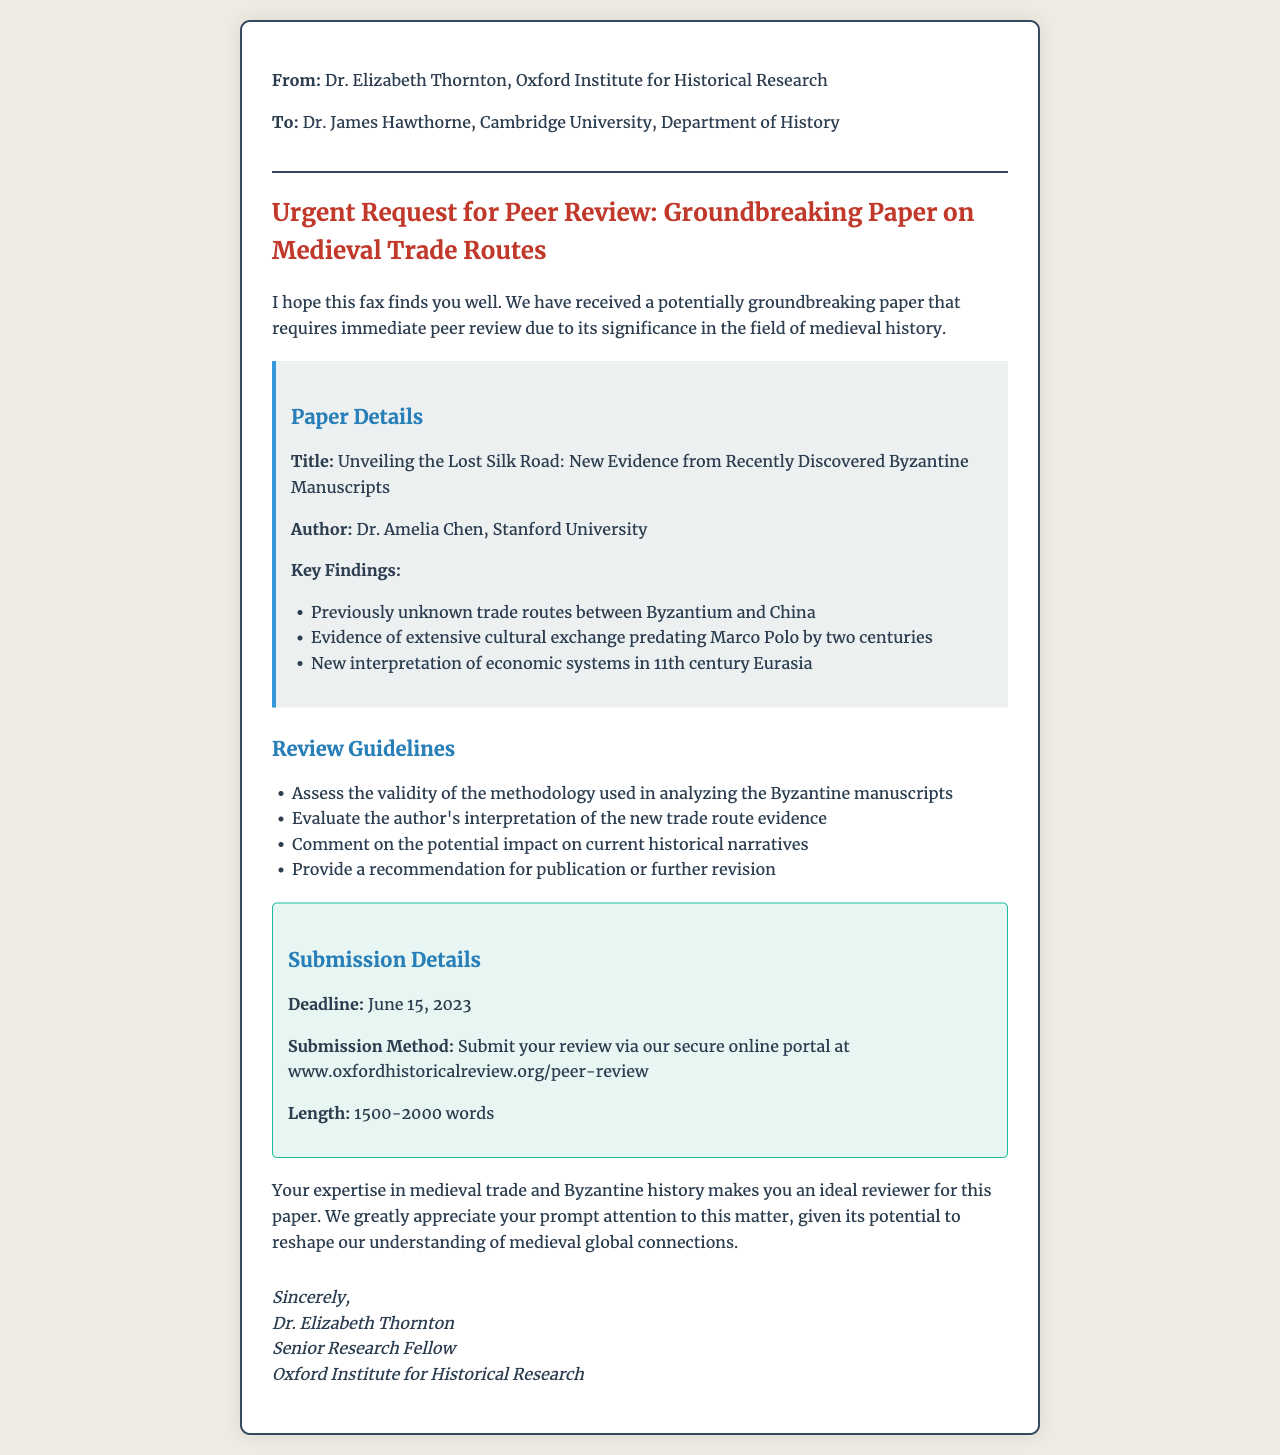What is the title of the paper? The title of the paper is specified in the document under "Paper Details."
Answer: Unveiling the Lost Silk Road: New Evidence from Recently Discovered Byzantine Manuscripts Who is the author of the paper? The author's name is provided in the same section as the title of the paper.
Answer: Dr. Amelia Chen What is the deadline for submission? The deadline for submission is clearly outlined in the "Submission Details" section of the document.
Answer: June 15, 2023 What is the recommended length of the review? The document specifies the acceptable length of the review in the "Submission Details" section.
Answer: 1500-2000 words What key finding reflects extensive cultural exchange? The document lists key findings in the "Paper Details" section, with one specifically addressing cultural exchange.
Answer: Evidence of extensive cultural exchange predating Marco Polo by two centuries What is the submission method? The submission method is described in the "Submission Details" section and indicates how to submit the review.
Answer: Submit your review via our secure online portal at www.oxfordhistoricalreview.org/peer-review What type of document is this? The structure and format of the document, along with its content, suggest the type of document it is.
Answer: Fax Why is Dr. James Hawthorne an ideal reviewer? The text mentions Dr. James's expertise as a reason for being an ideal reviewer, linking it to the paper's content.
Answer: His expertise in medieval trade and Byzantine history What area of history does the paper focus on? The document identifies the focus area of the paper within the introductory section and the title.
Answer: Medieval history 